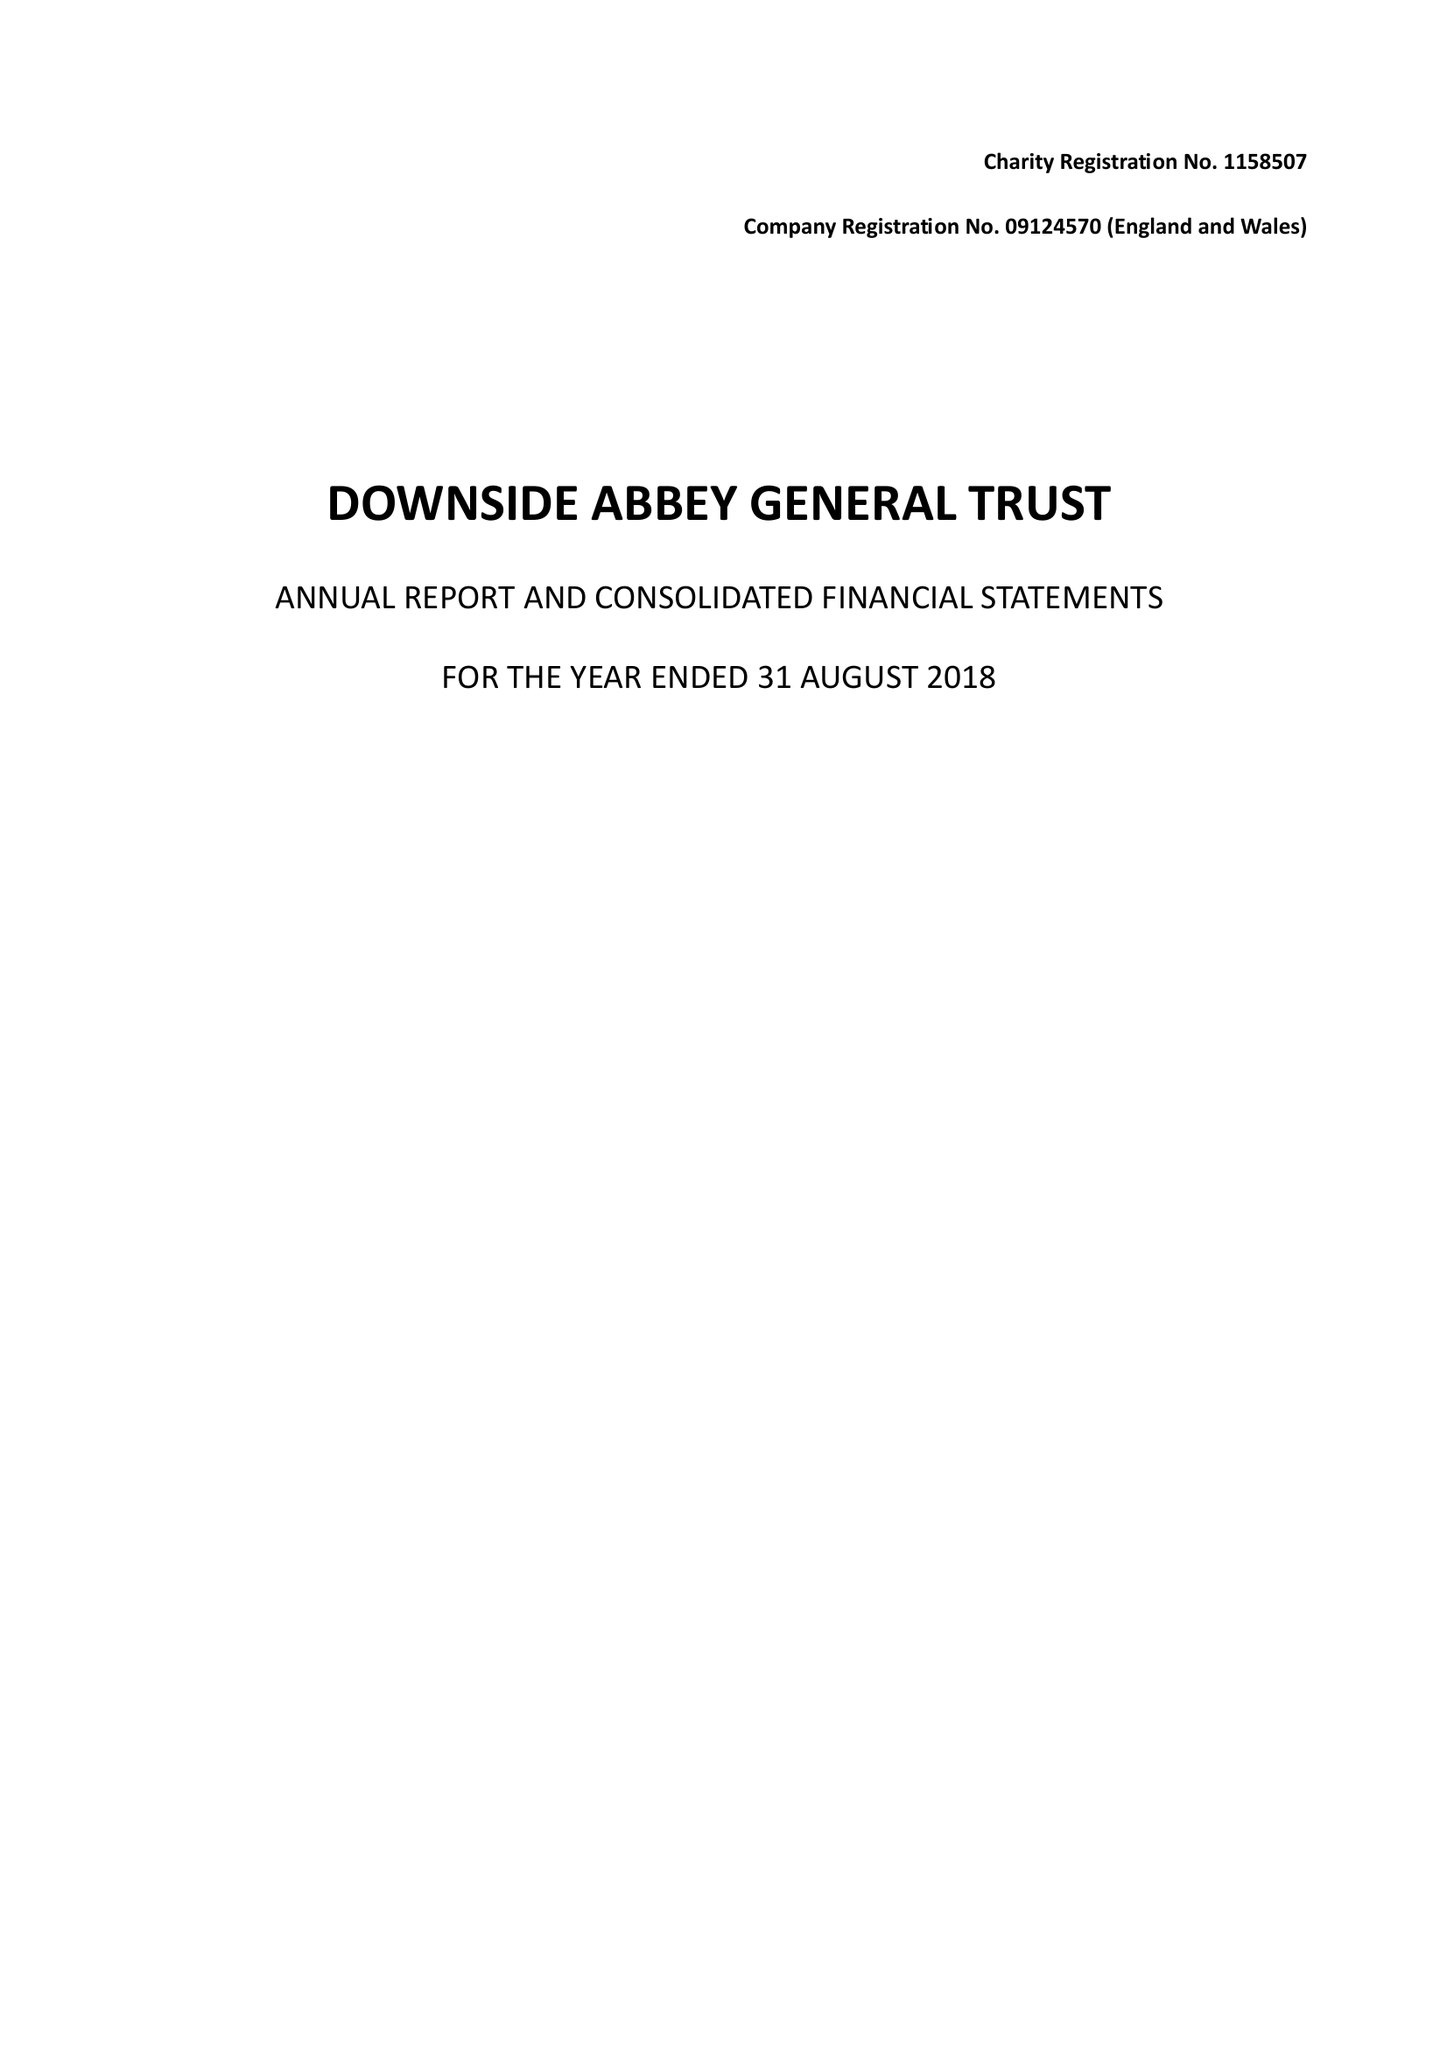What is the value for the charity_name?
Answer the question using a single word or phrase. Downside Abbey General Trust 